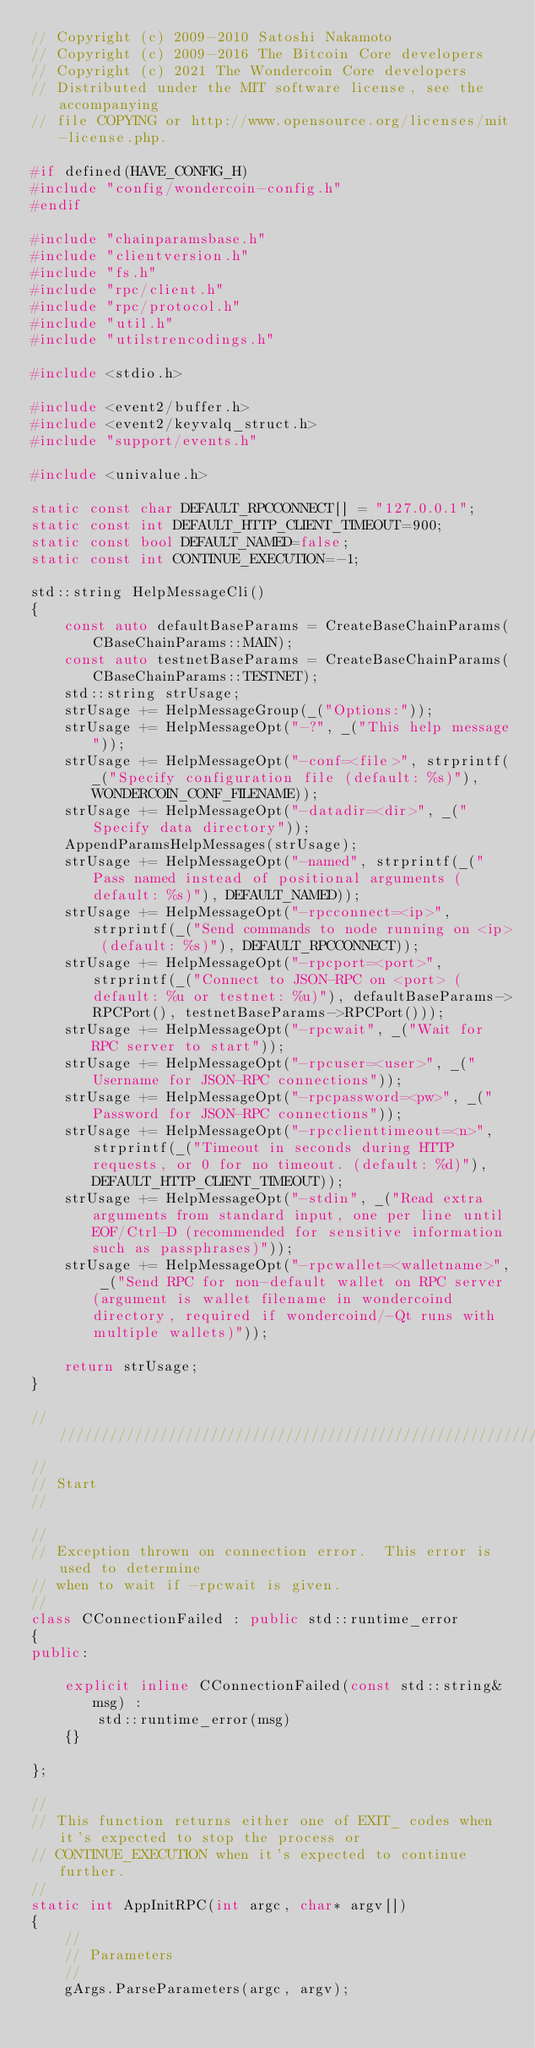<code> <loc_0><loc_0><loc_500><loc_500><_C++_>// Copyright (c) 2009-2010 Satoshi Nakamoto
// Copyright (c) 2009-2016 The Bitcoin Core developers
// Copyright (c) 2021 The Wondercoin Core developers
// Distributed under the MIT software license, see the accompanying
// file COPYING or http://www.opensource.org/licenses/mit-license.php.

#if defined(HAVE_CONFIG_H)
#include "config/wondercoin-config.h"
#endif

#include "chainparamsbase.h"
#include "clientversion.h"
#include "fs.h"
#include "rpc/client.h"
#include "rpc/protocol.h"
#include "util.h"
#include "utilstrencodings.h"

#include <stdio.h>

#include <event2/buffer.h>
#include <event2/keyvalq_struct.h>
#include "support/events.h"

#include <univalue.h>

static const char DEFAULT_RPCCONNECT[] = "127.0.0.1";
static const int DEFAULT_HTTP_CLIENT_TIMEOUT=900;
static const bool DEFAULT_NAMED=false;
static const int CONTINUE_EXECUTION=-1;

std::string HelpMessageCli()
{
    const auto defaultBaseParams = CreateBaseChainParams(CBaseChainParams::MAIN);
    const auto testnetBaseParams = CreateBaseChainParams(CBaseChainParams::TESTNET);
    std::string strUsage;
    strUsage += HelpMessageGroup(_("Options:"));
    strUsage += HelpMessageOpt("-?", _("This help message"));
    strUsage += HelpMessageOpt("-conf=<file>", strprintf(_("Specify configuration file (default: %s)"), WONDERCOIN_CONF_FILENAME));
    strUsage += HelpMessageOpt("-datadir=<dir>", _("Specify data directory"));
    AppendParamsHelpMessages(strUsage);
    strUsage += HelpMessageOpt("-named", strprintf(_("Pass named instead of positional arguments (default: %s)"), DEFAULT_NAMED));
    strUsage += HelpMessageOpt("-rpcconnect=<ip>", strprintf(_("Send commands to node running on <ip> (default: %s)"), DEFAULT_RPCCONNECT));
    strUsage += HelpMessageOpt("-rpcport=<port>", strprintf(_("Connect to JSON-RPC on <port> (default: %u or testnet: %u)"), defaultBaseParams->RPCPort(), testnetBaseParams->RPCPort()));
    strUsage += HelpMessageOpt("-rpcwait", _("Wait for RPC server to start"));
    strUsage += HelpMessageOpt("-rpcuser=<user>", _("Username for JSON-RPC connections"));
    strUsage += HelpMessageOpt("-rpcpassword=<pw>", _("Password for JSON-RPC connections"));
    strUsage += HelpMessageOpt("-rpcclienttimeout=<n>", strprintf(_("Timeout in seconds during HTTP requests, or 0 for no timeout. (default: %d)"), DEFAULT_HTTP_CLIENT_TIMEOUT));
    strUsage += HelpMessageOpt("-stdin", _("Read extra arguments from standard input, one per line until EOF/Ctrl-D (recommended for sensitive information such as passphrases)"));
    strUsage += HelpMessageOpt("-rpcwallet=<walletname>", _("Send RPC for non-default wallet on RPC server (argument is wallet filename in wondercoind directory, required if wondercoind/-Qt runs with multiple wallets)"));

    return strUsage;
}

//////////////////////////////////////////////////////////////////////////////
//
// Start
//

//
// Exception thrown on connection error.  This error is used to determine
// when to wait if -rpcwait is given.
//
class CConnectionFailed : public std::runtime_error
{
public:

    explicit inline CConnectionFailed(const std::string& msg) :
        std::runtime_error(msg)
    {}

};

//
// This function returns either one of EXIT_ codes when it's expected to stop the process or
// CONTINUE_EXECUTION when it's expected to continue further.
//
static int AppInitRPC(int argc, char* argv[])
{
    //
    // Parameters
    //
    gArgs.ParseParameters(argc, argv);</code> 